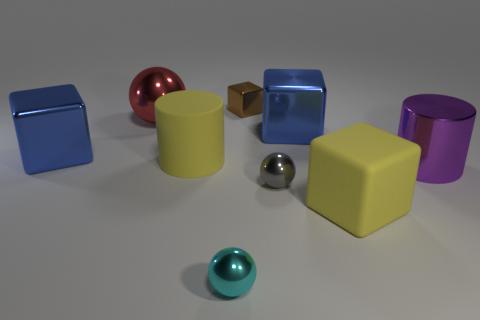Subtract all gray cubes. Subtract all green cylinders. How many cubes are left? 4 Add 1 yellow rubber cylinders. How many objects exist? 10 Subtract all spheres. How many objects are left? 6 Add 6 brown things. How many brown things exist? 7 Subtract 1 blue cubes. How many objects are left? 8 Subtract all cyan cubes. Subtract all large shiny spheres. How many objects are left? 8 Add 1 small gray balls. How many small gray balls are left? 2 